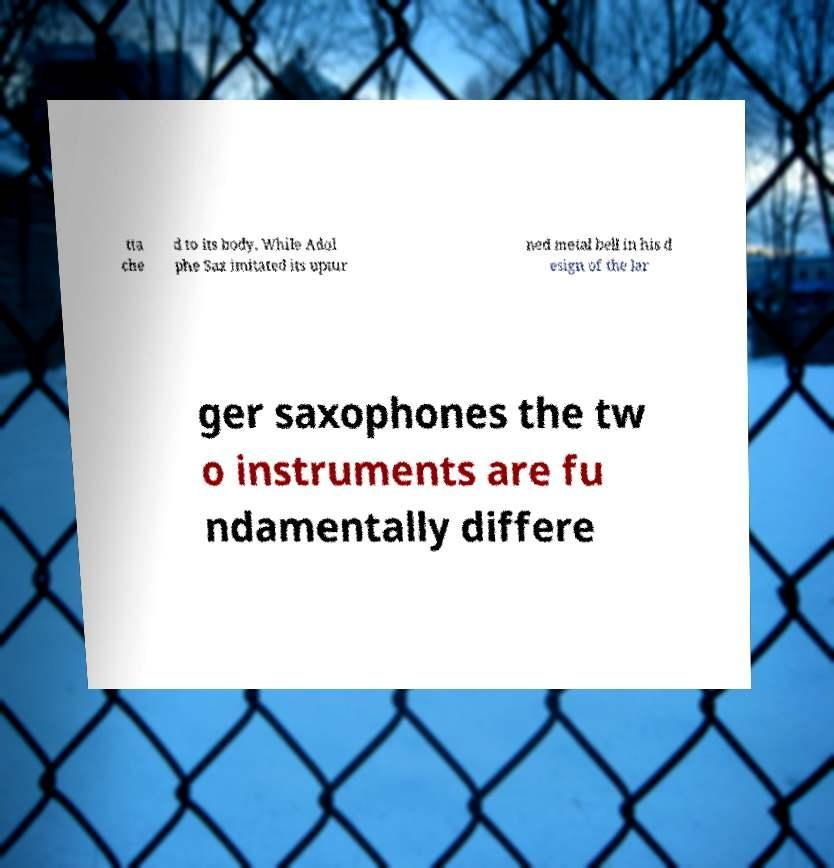Please identify and transcribe the text found in this image. tta che d to its body. While Adol phe Sax imitated its uptur ned metal bell in his d esign of the lar ger saxophones the tw o instruments are fu ndamentally differe 